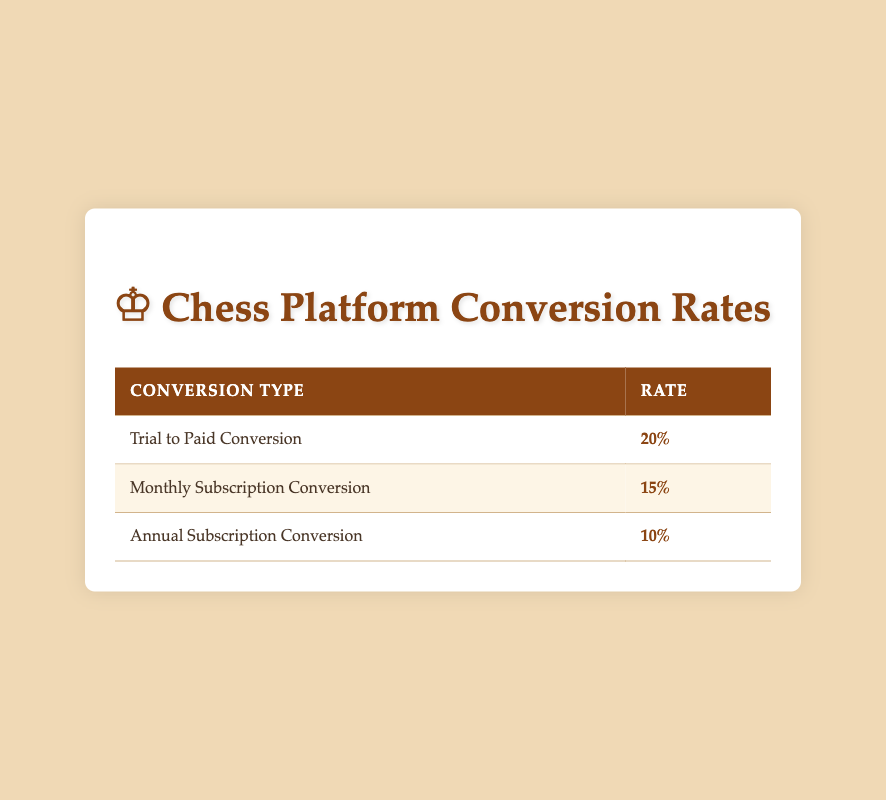What is the trial to paid conversion rate? The table directly states that the trial to paid conversion rate is 20%.
Answer: 20% What is the engagement rate for users aged 18-24? The engagement rate for the age group 18-24 is listed in the user demographics section, specifically as 0.5.
Answer: 0.5 How many users are in the 25-34 age group? The total number of users in the 25-34 age group is shown in the user demographics, which is 25,000.
Answer: 25000 Is the engagement rate for females higher than the engagement rate for males? The female engagement rate is 0.48, while the male engagement rate is 0.46. Since 0.48 is greater than 0.46, the statement is true.
Answer: Yes What is the average engagement rate across all age groups? To find the average engagement rate, you sum the engagement rates of each group: (0.35 + 0.5 + 0.45 + 0.4 + 0.3) = 2.0. There are 5 age groups, so the average is 2.0 / 5 = 0.4.
Answer: 0.4 Which geographical region has the highest engagement rate? Looking at the geographical distribution, Europe has the highest engagement rate of 0.55.
Answer: Europe If there are 10,000 users in trials, how many are expected to convert to paid? To find out how many users are expected to convert, multiply the number of trial users (10,000) by the conversion rate (0.2): 10,000 * 0.2 = 2,000.
Answer: 2000 What is the total number of users across all gender distributions? The total number of users for males is 42,000, females is 10,000, and non-binary is 3,000. Summing these together gives us 42,000 + 10,000 + 3,000 = 55,000.
Answer: 55000 Would you say that the percentage of users participating in tournaments is relatively low? The table states that 15% of users participate in tournaments. Given the context of engagement metrics, 15% is relatively low compared to other types of sports or hobbies.
Answer: Yes 